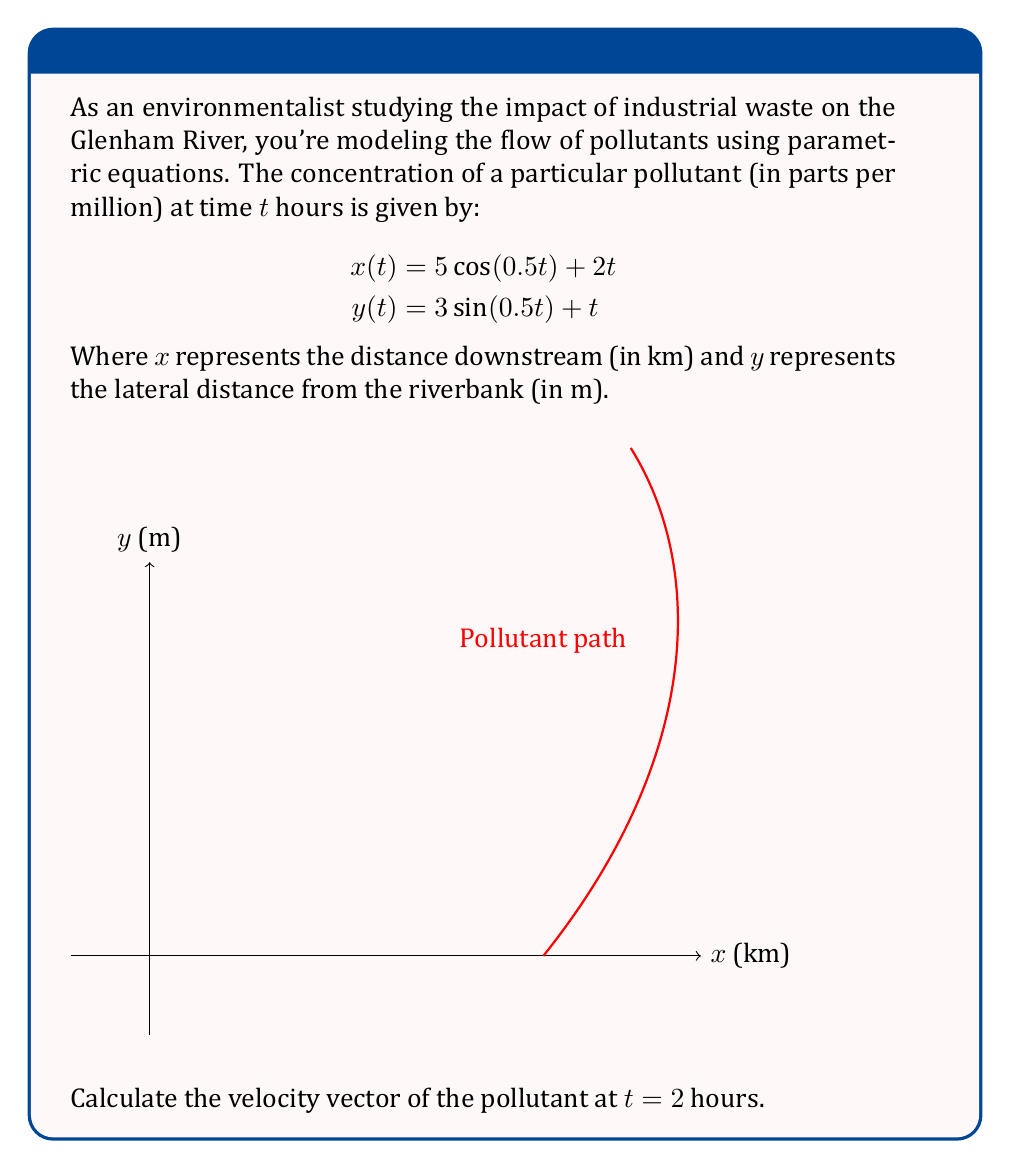Teach me how to tackle this problem. To find the velocity vector at $t = 2$ hours, we need to follow these steps:

1) The velocity vector is given by the first derivative of the position vector with respect to time. In parametric form, this is:

   $$\vec{v}(t) = \left(\frac{dx}{dt}, \frac{dy}{dt}\right)$$

2) Let's calculate $\frac{dx}{dt}$:
   
   $$\begin{aligned}
   \frac{dx}{dt} &= \frac{d}{dt}[5\cos(0.5t) + 2t] \\
   &= 5 \cdot (-0.5\sin(0.5t)) + 2 \\
   &= -2.5\sin(0.5t) + 2
   \end{aligned}$$

3) Now, let's calculate $\frac{dy}{dt}$:
   
   $$\begin{aligned}
   \frac{dy}{dt} &= \frac{d}{dt}[3\sin(0.5t) + t] \\
   &= 3 \cdot (0.5\cos(0.5t)) + 1 \\
   &= 1.5\cos(0.5t) + 1
   \end{aligned}$$

4) Therefore, the velocity vector is:

   $$\vec{v}(t) = (-2.5\sin(0.5t) + 2, 1.5\cos(0.5t) + 1)$$

5) To find the velocity at $t = 2$, we substitute $t = 2$ into this expression:

   $$\begin{aligned}
   \vec{v}(2) &= (-2.5\sin(0.5 \cdot 2) + 2, 1.5\cos(0.5 \cdot 2) + 1) \\
   &= (-2.5\sin(1) + 2, 1.5\cos(1) + 1) \\
   &\approx (-0.092, 1.841)
   \end{aligned}$$

6) The units for the x-component are km/h, and for the y-component are m/h. To have consistent units, we should convert km/h to m/h:

   $$\vec{v}(2) \approx (-92, 1.841) \text{ m/h}$$
Answer: $\vec{v}(2) \approx (-92, 1.841) \text{ m/h}$ 